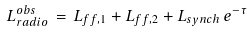Convert formula to latex. <formula><loc_0><loc_0><loc_500><loc_500>L _ { r a d i o } ^ { o b s } \, = \, L _ { f f , 1 } + L _ { f f , 2 } + L _ { s y n c h } \, e ^ { - \tau }</formula> 